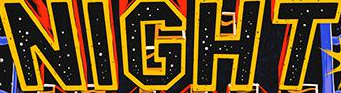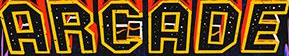Transcribe the words shown in these images in order, separated by a semicolon. NIGHT; ARGADE 